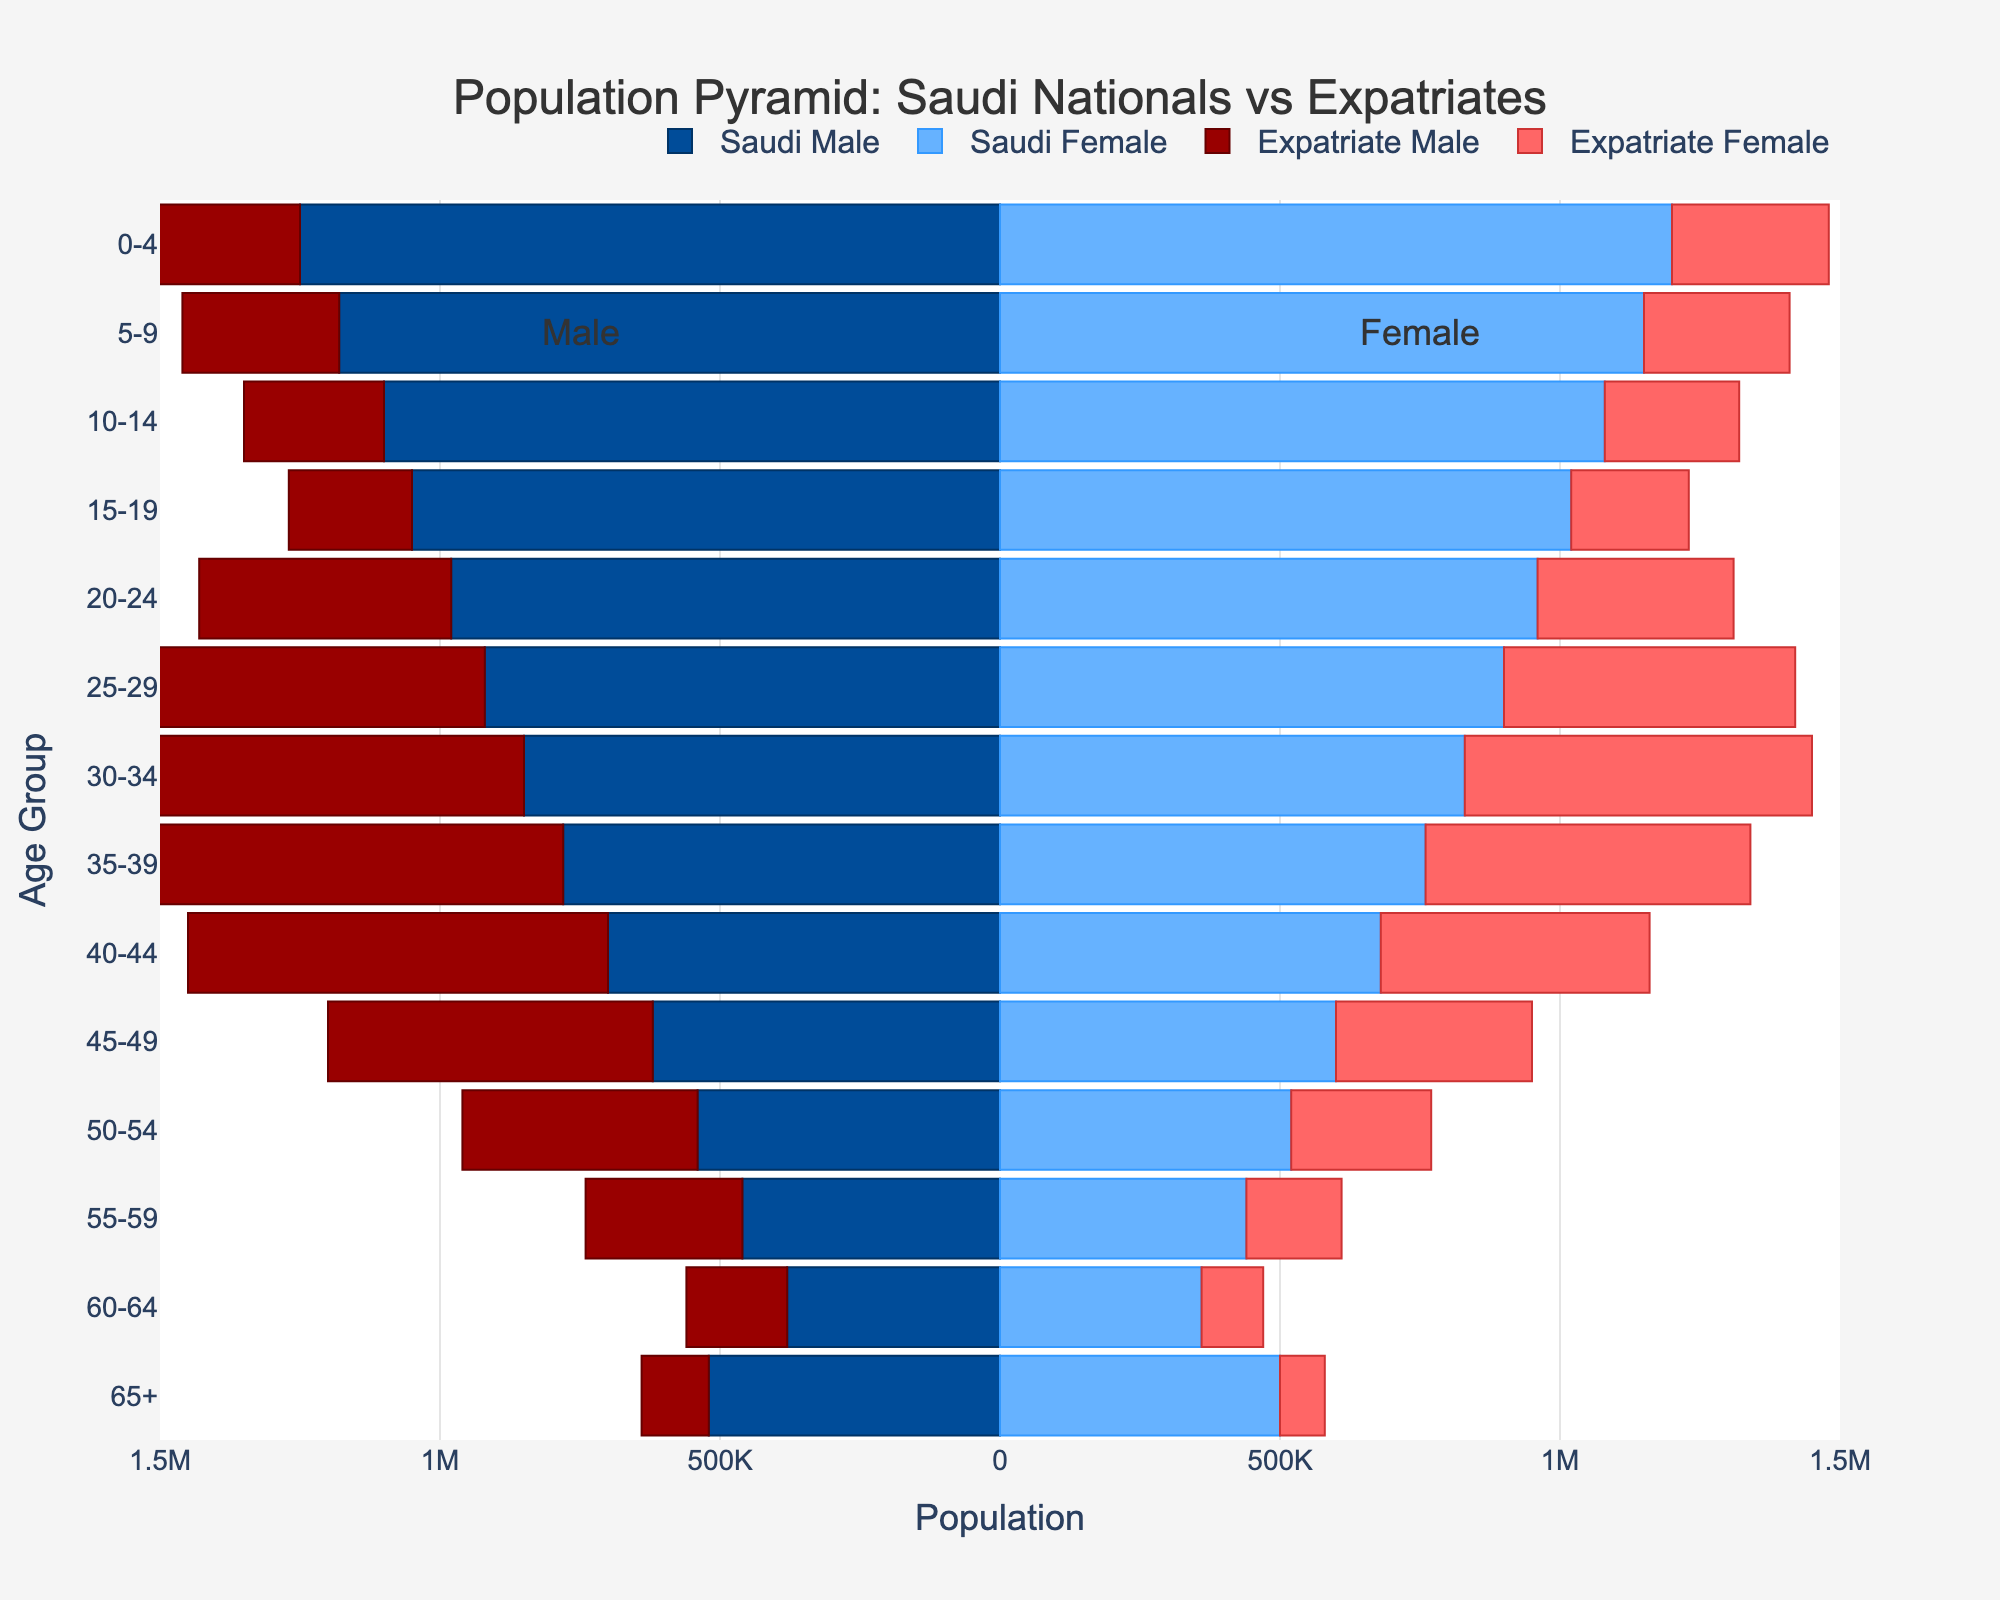Which age group has the highest population of Saudi Males? To determine which age group has the highest population of Saudi Males, look at the bar lengths for all the age groups on the Saudi Males side. The longest bar indicates the highest population. The 0-4 age group has the longest bar.
Answer: 0-4 Which gender has more expatriates in the 25-29 age group? Compare the length of the bars representing Expatriate Males and Expatriate Females in the 25-29 age group. The Expatriate Male bar is longer than the Expatriate Female bar.
Answer: Expatriate Males What is the approximate difference in the population of Saudi Nationals aged 30-34 and Expatriates aged 30-34? First, find the total population of Saudi Nationals aged 30-34, which is the sum of Saudi Males and Females (850,000 + 830,000). Then, find the total population of Expatriates aged 30-34 (950,000 + 620,000). Finally, take the absolute difference between these two totals.
Answer: 90,000 Which gender has a higher population in the age group 65+ for both Saudi Nationals and Expatriates? For Saudi Nationals and Expatriates, look at the 65+ age group bars for both Males and Females. Compare the lengths of the bars. Both Saudi Females and Expatriate Females have longer bars than their male counterparts.
Answer: Females Are there more Saudi Males or Expatriate Males in the 20-24 age group? Look at the bars representing Saudi Males and Expatriate Males in the 20-24 age group. Compare their lengths. The bar for Expatriate Males is longer than that for Saudi Males.
Answer: Expatriate Males Which age group has the smallest difference in the population between Saudi Males and Saudi Females? For each age group, find the absolute difference between the populations of Saudi Males and Saudi Females, and then see which age group has the smallest difference. The 0-4 age group has the smallest difference.
Answer: 0-4 What is the pattern between age groups for the expatriate population in terms of gender? Analyze the bars for Expatriate Males and Females across different age groups. Identify whether there are any consistent patterns or trends. Expatriate Males consistently have a higher population than Expatriate Females in almost all age groups.
Answer: Males > Females Comparing the Saudi population in the 40-44 age group, which gender has more population and by how much? Find the length of the bars representing Saudi Males and Saudi Females in the 40-44 age group. Subtract the smaller population from the larger one to find the difference. The Saudi Male population is higher than the Saudi Female population by 20,000.
Answer: Saudi Males, 20,000 How does the expatriate population in the 55-59 age group compare to that in the 50-54 age group? Look at the bars for Expatriate Males and Females in both the 55-59 and 50-54 age groups. Compare the lengths of the respective bars between these two age groups. The expatriate population is higher in the 50-54 age group compared to the 55-59 age group.
Answer: Higher in 50-54 